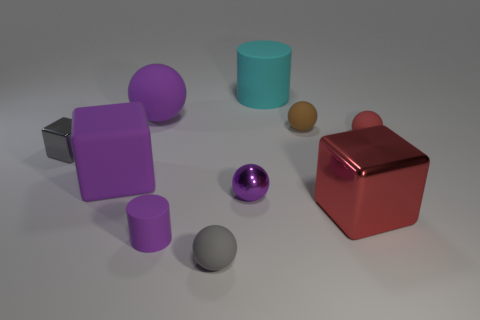Subtract all yellow blocks. How many purple spheres are left? 2 Subtract all big spheres. How many spheres are left? 4 Subtract all brown balls. How many balls are left? 4 Subtract all blocks. How many objects are left? 7 Subtract 3 spheres. How many spheres are left? 2 Subtract all green cubes. Subtract all blue cylinders. How many cubes are left? 3 Subtract all rubber blocks. Subtract all large balls. How many objects are left? 8 Add 6 large purple cubes. How many large purple cubes are left? 7 Add 4 tiny blue balls. How many tiny blue balls exist? 4 Subtract 1 brown spheres. How many objects are left? 9 